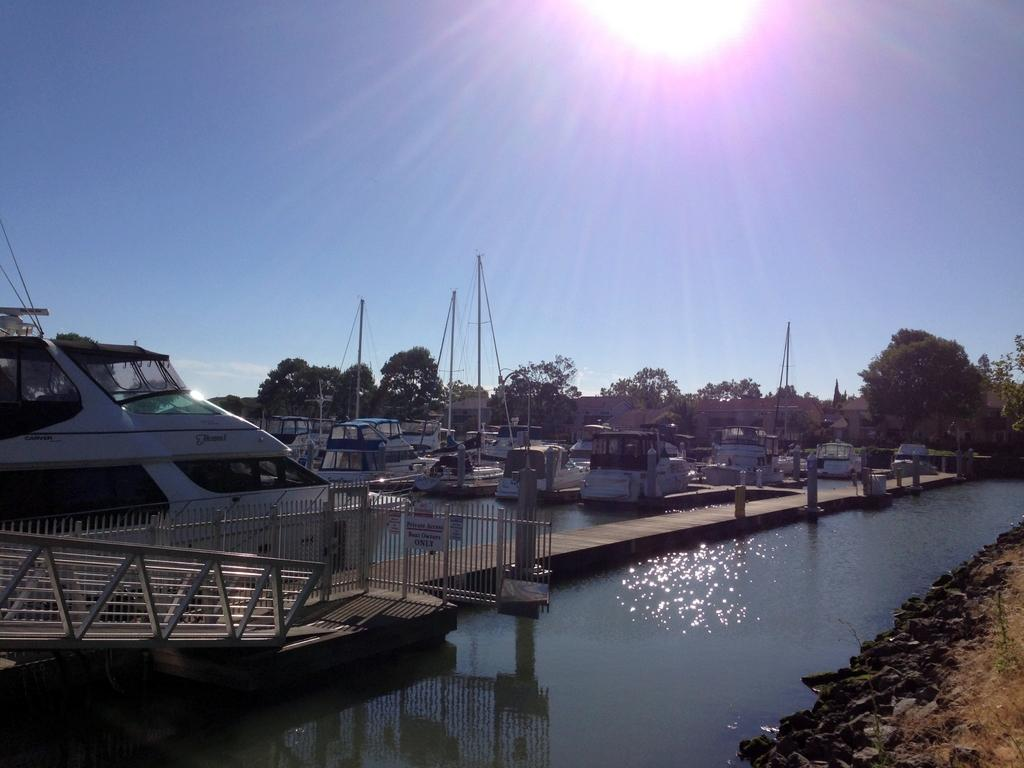What type of vehicles can be seen in the image? There are ships at the deck in the image. What body of water is visible in the image? There is a river visible in the image. What type of vegetation is present in the image? There are trees in the image. What structures can be seen in the image? There are poles in the image. What part of the natural environment is visible in the image? The sky is visible in the image. What type of terrain is visible in the image? There are stones and the ground visible in the image. Can the sun be seen in the image? Yes, the sun is observable in the sky. What type of canvas is being used for the punishment in the image? There is no canvas or punishment present in the image. What type of iron is being used to hold the ships in place in the image? There is no iron or indication of ships being held in place in the image; they are on a deck. 